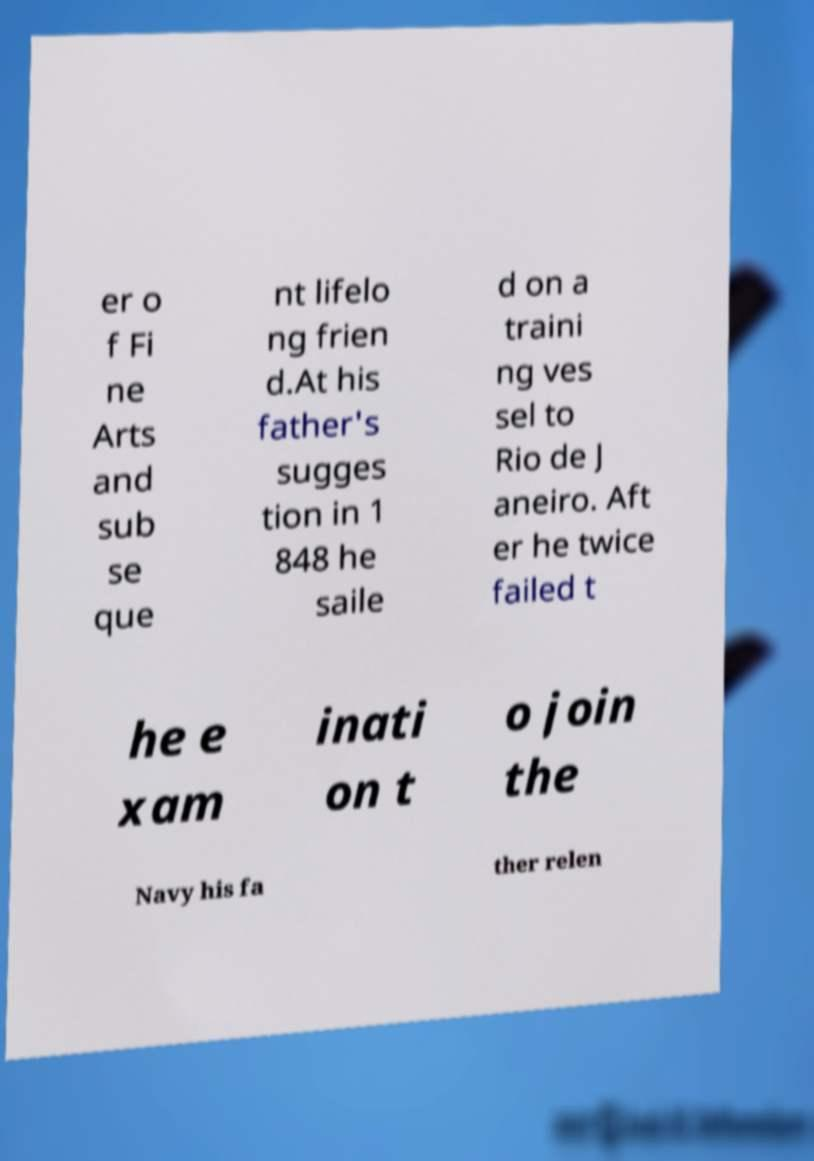What messages or text are displayed in this image? I need them in a readable, typed format. er o f Fi ne Arts and sub se que nt lifelo ng frien d.At his father's sugges tion in 1 848 he saile d on a traini ng ves sel to Rio de J aneiro. Aft er he twice failed t he e xam inati on t o join the Navy his fa ther relen 